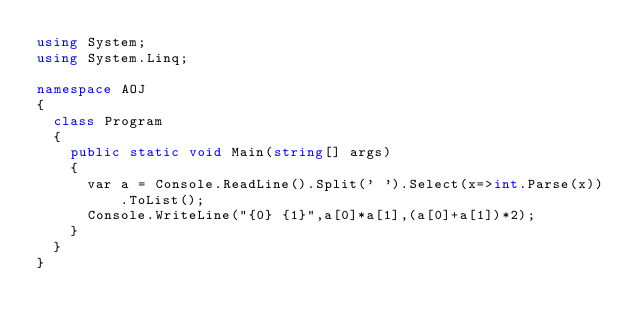<code> <loc_0><loc_0><loc_500><loc_500><_C#_>using System;
using System.Linq;

namespace AOJ
{
	class Program
	{
		public static void Main(string[] args)
		{
			var a = Console.ReadLine().Split(' ').Select(x=>int.Parse(x)).ToList();
			Console.WriteLine("{0} {1}",a[0]*a[1],(a[0]+a[1])*2);
		}
	}
}</code> 